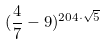Convert formula to latex. <formula><loc_0><loc_0><loc_500><loc_500>( \frac { 4 } { 7 } - 9 ) ^ { 2 0 4 \cdot \sqrt { 5 } }</formula> 